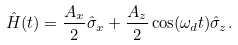<formula> <loc_0><loc_0><loc_500><loc_500>\hat { H } ( t ) = \frac { A _ { x } } { 2 } \hat { \sigma } _ { x } + \frac { A _ { z } } { 2 } \cos ( \omega _ { d } t ) \hat { \sigma } _ { z } .</formula> 